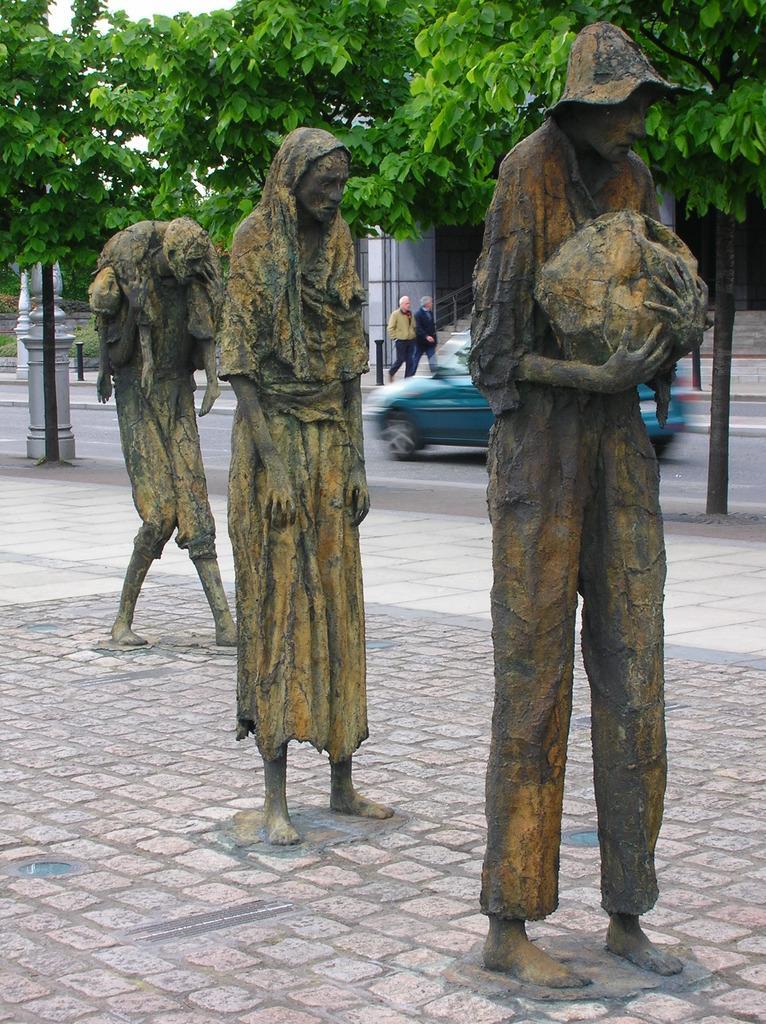Describe this image in one or two sentences. In the center of the image we can see statues on the ground. In the background we can see trees, car, road, persons and building. 